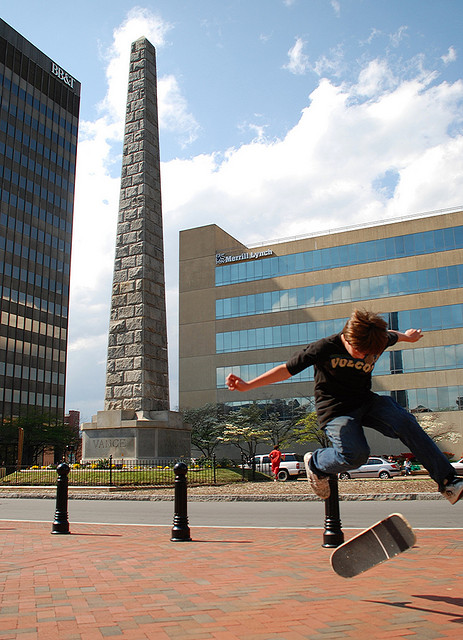<image>What is the monument in the background? I am not sure about what the monument in the background. It could be a tower, obelisk, Washington, war memorial or a large pillar. What is the monument in the background? I am not sure what is the monument in the background. It can be seen as 'large pillar', 'stone', 'washington', 'tower', 'war memorial', or 'obelisk'. 